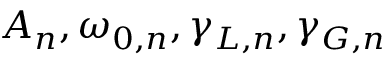Convert formula to latex. <formula><loc_0><loc_0><loc_500><loc_500>A _ { n } , \omega _ { 0 , n } , \gamma _ { L , n } , \gamma _ { G , n }</formula> 